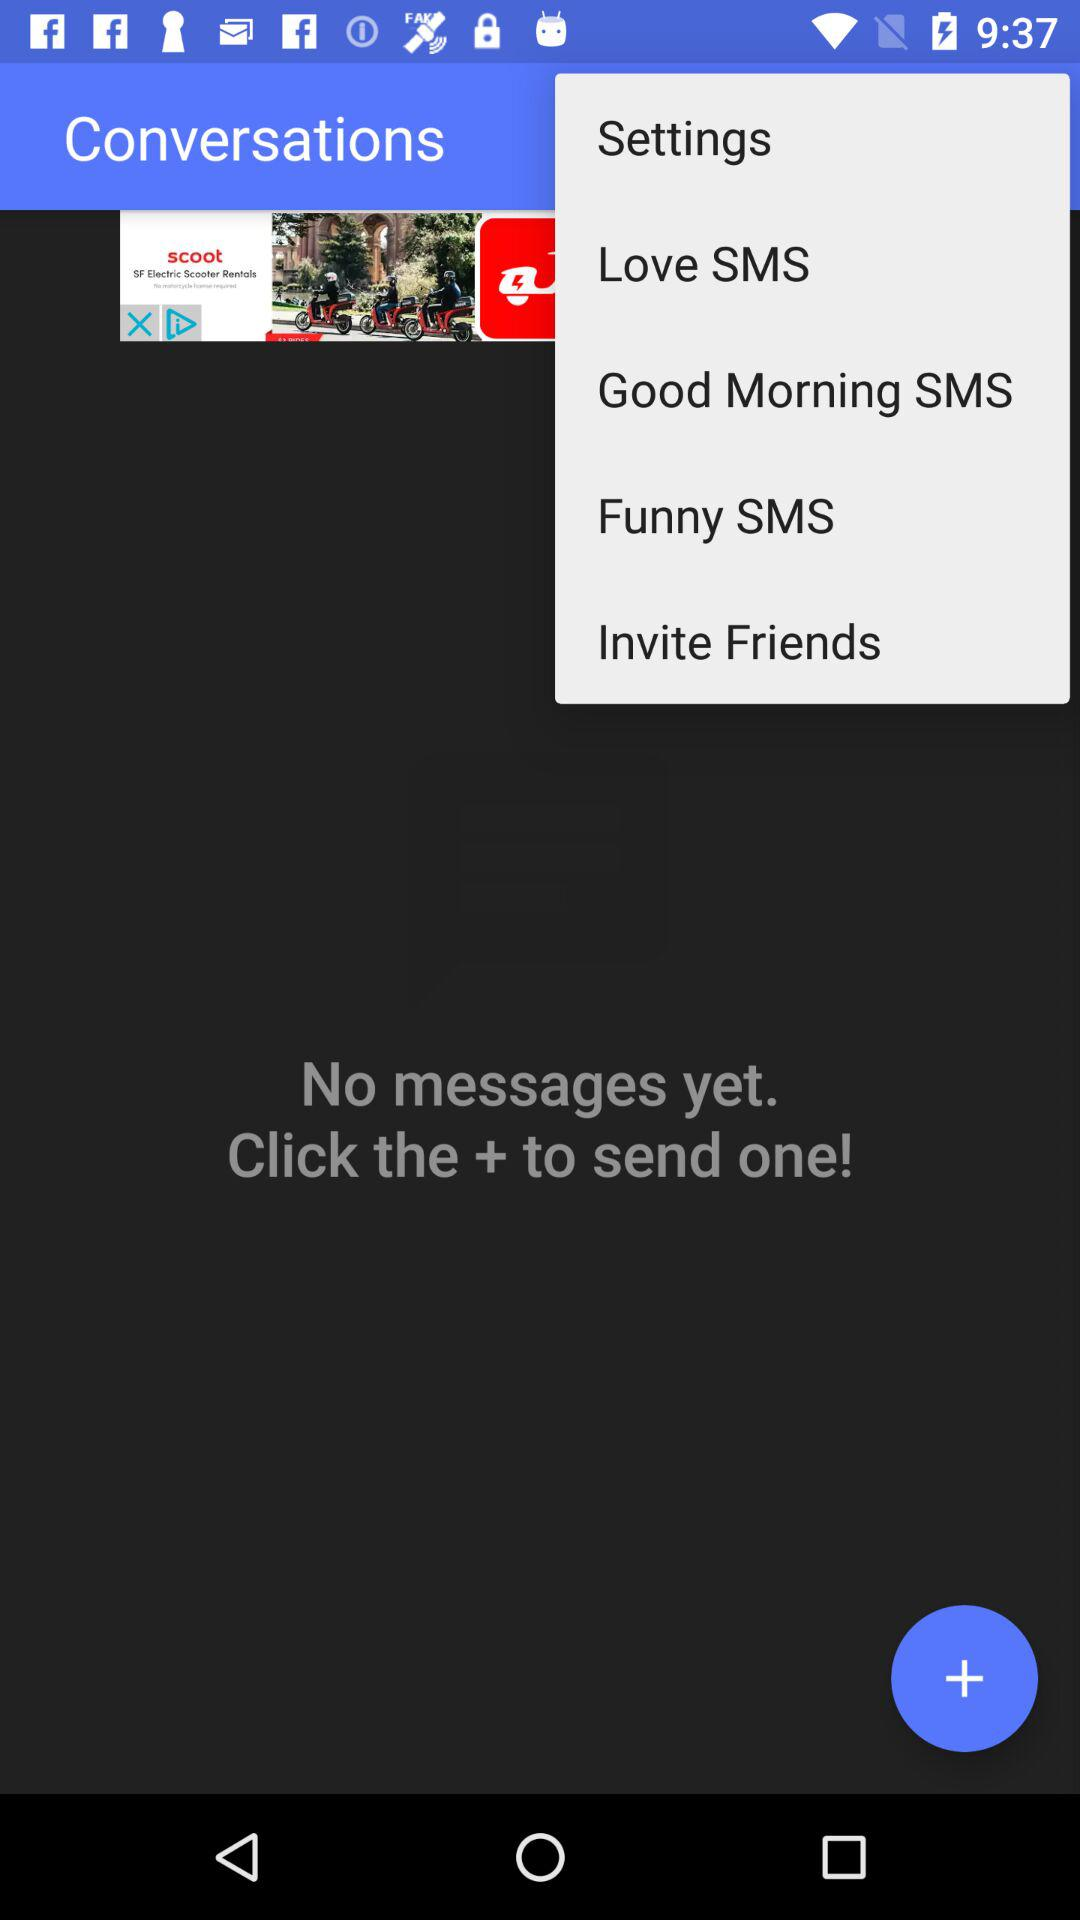How many messages are there? There are no messages. 